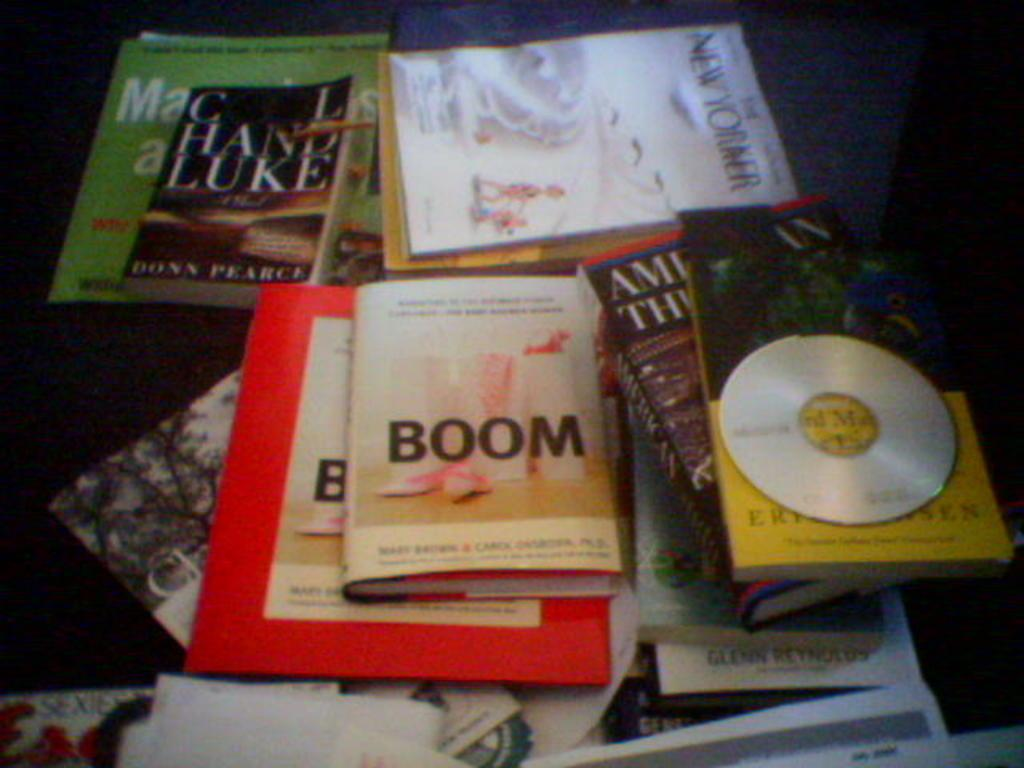Provide a one-sentence caption for the provided image. A book titled Boom lies on a table with other books and a CD. 